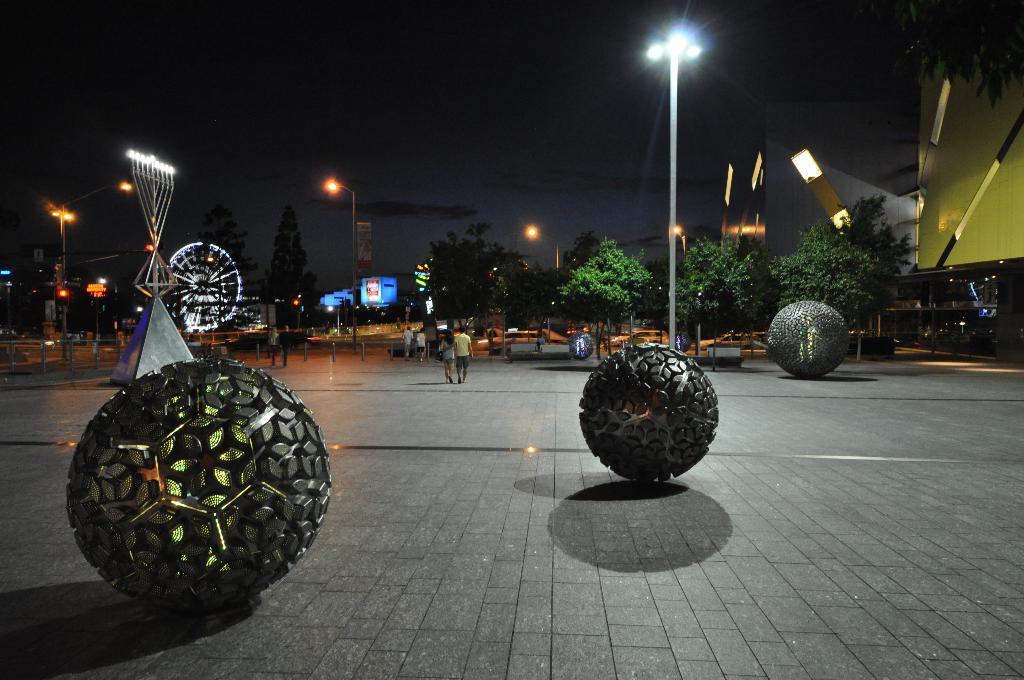Can you describe this image briefly? In this picture we can see one some balls are placed on the road, some people are walking on the road and there are some buildings. 